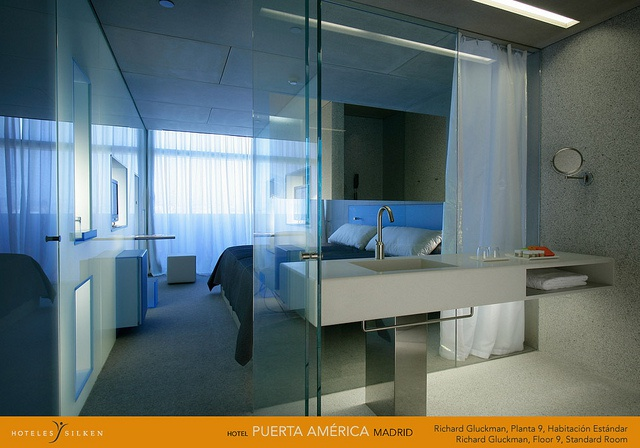Describe the objects in this image and their specific colors. I can see sink in black, darkgray, and gray tones, bed in black, blue, and gray tones, bed in black, navy, blue, and purple tones, laptop in black, blue, and darkblue tones, and tv in black, lightblue, and white tones in this image. 